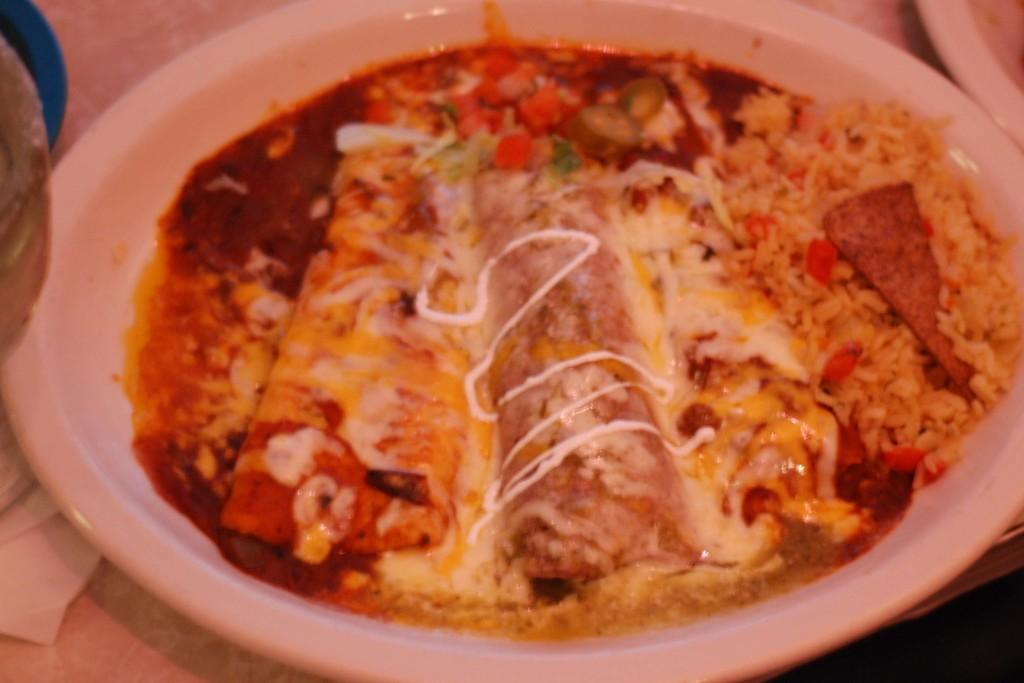What is present on the plate in the image? The plate is filled with food items. Is there a market visible in the image? No, there is no market present in the image. Does the existence of the plate in the image prove the existence of the universe? The presence of the plate in the image does not prove the existence of the universe, as the image is a small part of the universe and cannot represent the entirety of its existence. 